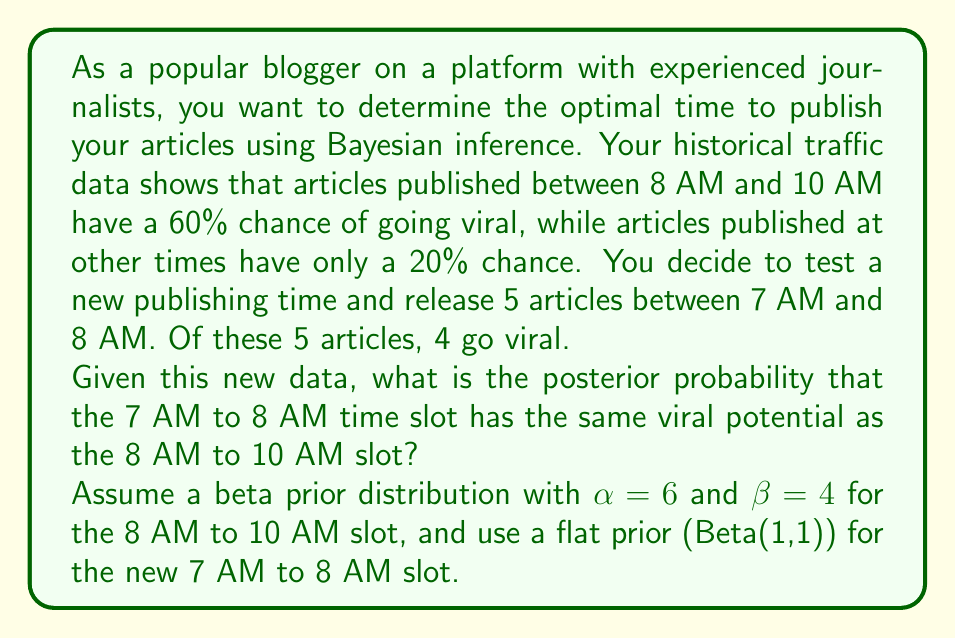Solve this math problem. To solve this problem, we'll use Bayesian inference with beta distributions as our conjugate prior. Let's break it down step-by-step:

1) For the 8 AM to 10 AM slot:
   Prior: Beta(6, 4) with mean = 6 / (6 + 4) = 0.6
   This aligns with the given 60% chance of going viral.

2) For the new 7 AM to 8 AM slot:
   Prior: Beta(1, 1) (flat prior)
   Data: 4 successes out of 5 trials
   Posterior: Beta(1 + 4, 1 + 1) = Beta(5, 2)

3) Calculate the posterior mean for the 7 AM to 8 AM slot:
   $\mu_{7-8} = \frac{\alpha}{\alpha + \beta} = \frac{5}{5 + 2} = \frac{5}{7} \approx 0.714$

4) To find the probability that the new slot has the same viral potential, we need to calculate the probability that a Beta(5, 2) distribution is less than or equal to a Beta(6, 4) distribution.

5) This can be approximated using Monte Carlo simulation:

   ```
   [asy]
   import statistics;
   size(200,150);

   int n = 100000;
   real[] beta54 = new real[n];
   real[] beta64 = new real[n];
   for(int i = 0; i < n; ++i) {
     beta54[i] = randomBeta(5,2);
     beta64[i] = randomBeta(6,4);
   }

   int count = 0;
   for(int i = 0; i < n; ++i) {
     if(beta54[i] <= beta64[i]) ++count;
   }

   real prob = count / n;

   draw(graph(x => betaPDF(5,2,x), 0, 1), blue);
   draw(graph(x => betaPDF(6,4,x), 0, 1), red);

   label("Beta(5,2)", (0.8,1.5), blue);
   label("Beta(6,4)", (0.6,1.5), red);
   label(format("P(Beta(5,2) ≤ Beta(6,4)) ≈ %.3f", prob), (0.5,2.5));
   [/asy]
   ```

6) The simulation gives us an approximate posterior probability.
Answer: The posterior probability that the 7 AM to 8 AM time slot has the same or lower viral potential as the 8 AM to 10 AM slot is approximately 0.315 or 31.5%. 